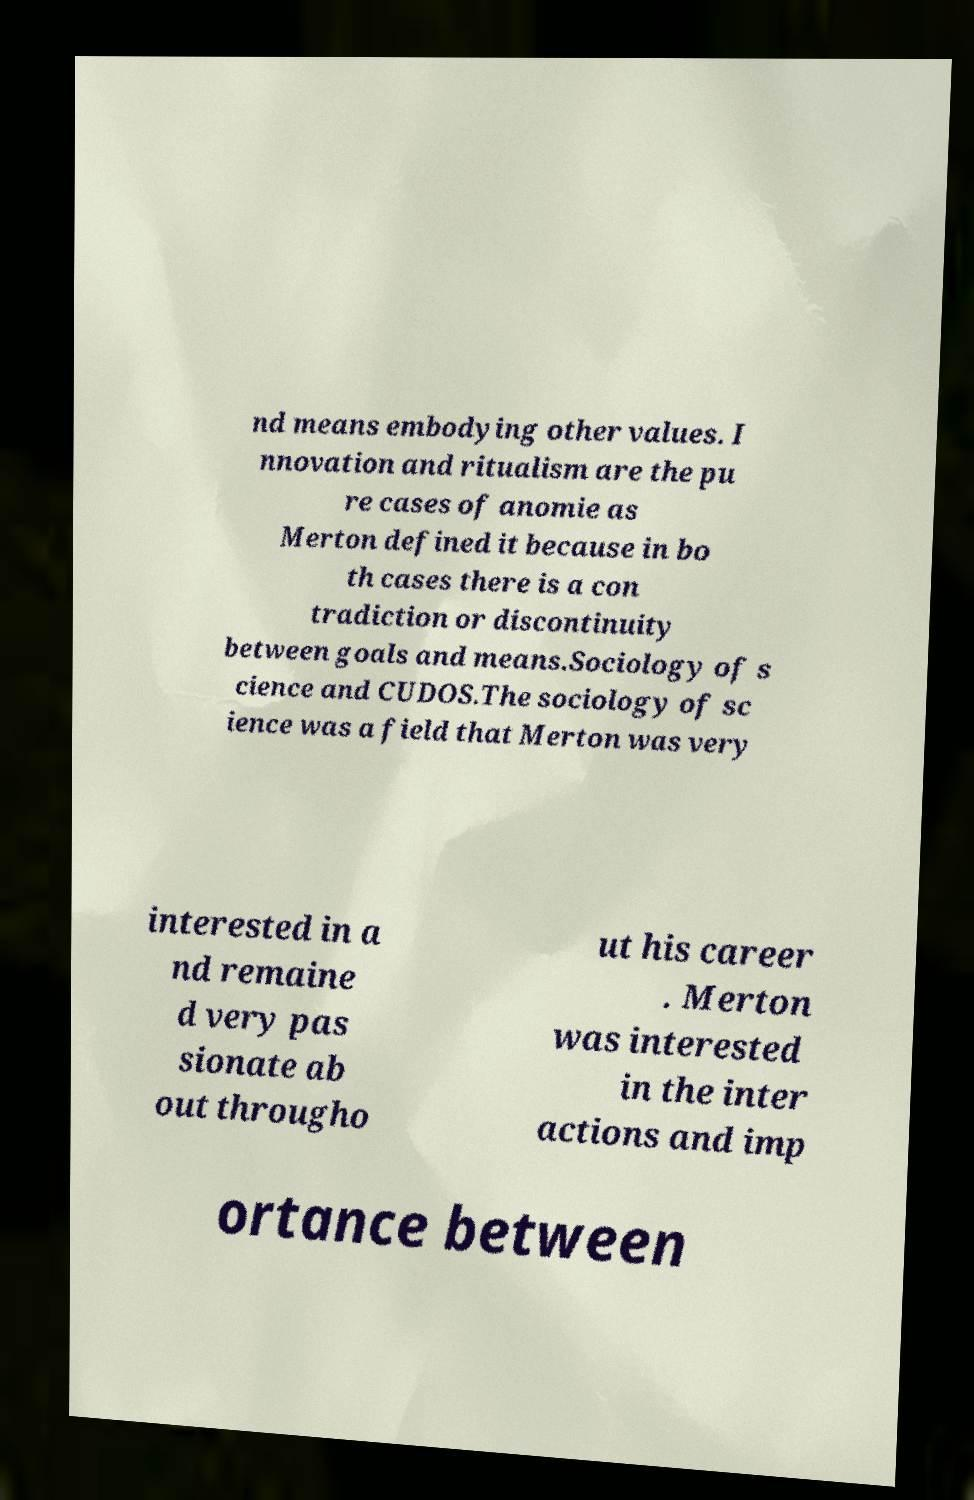What messages or text are displayed in this image? I need them in a readable, typed format. nd means embodying other values. I nnovation and ritualism are the pu re cases of anomie as Merton defined it because in bo th cases there is a con tradiction or discontinuity between goals and means.Sociology of s cience and CUDOS.The sociology of sc ience was a field that Merton was very interested in a nd remaine d very pas sionate ab out througho ut his career . Merton was interested in the inter actions and imp ortance between 